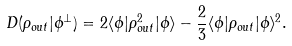<formula> <loc_0><loc_0><loc_500><loc_500>D ( \rho _ { o u t } | \phi ^ { \bot } ) = 2 \langle \phi | \rho _ { o u t } ^ { 2 } | \phi \rangle - \frac { 2 } { 3 } \langle \phi | \rho _ { o u t } | \phi \rangle ^ { 2 } .</formula> 